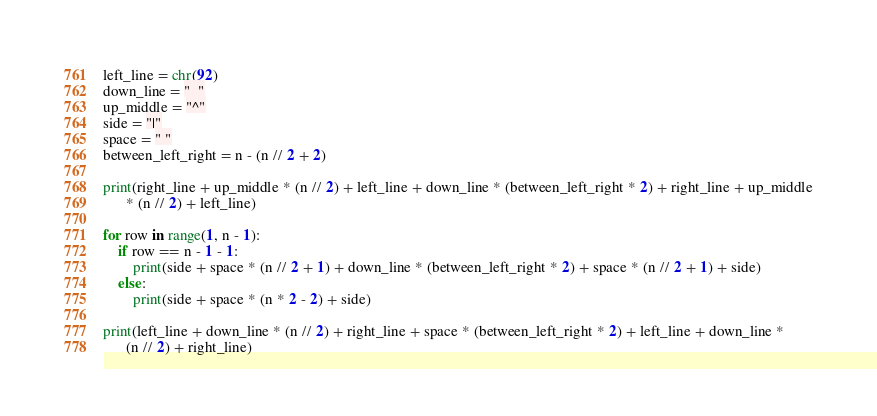Convert code to text. <code><loc_0><loc_0><loc_500><loc_500><_Python_>left_line = chr(92)
down_line = "_"
up_middle = "^"
side = "|"
space = " "
between_left_right = n - (n // 2 + 2)

print(right_line + up_middle * (n // 2) + left_line + down_line * (between_left_right * 2) + right_line + up_middle
      * (n // 2) + left_line)

for row in range(1, n - 1):
    if row == n - 1 - 1:
        print(side + space * (n // 2 + 1) + down_line * (between_left_right * 2) + space * (n // 2 + 1) + side)
    else:
        print(side + space * (n * 2 - 2) + side)

print(left_line + down_line * (n // 2) + right_line + space * (between_left_right * 2) + left_line + down_line *
      (n // 2) + right_line)</code> 